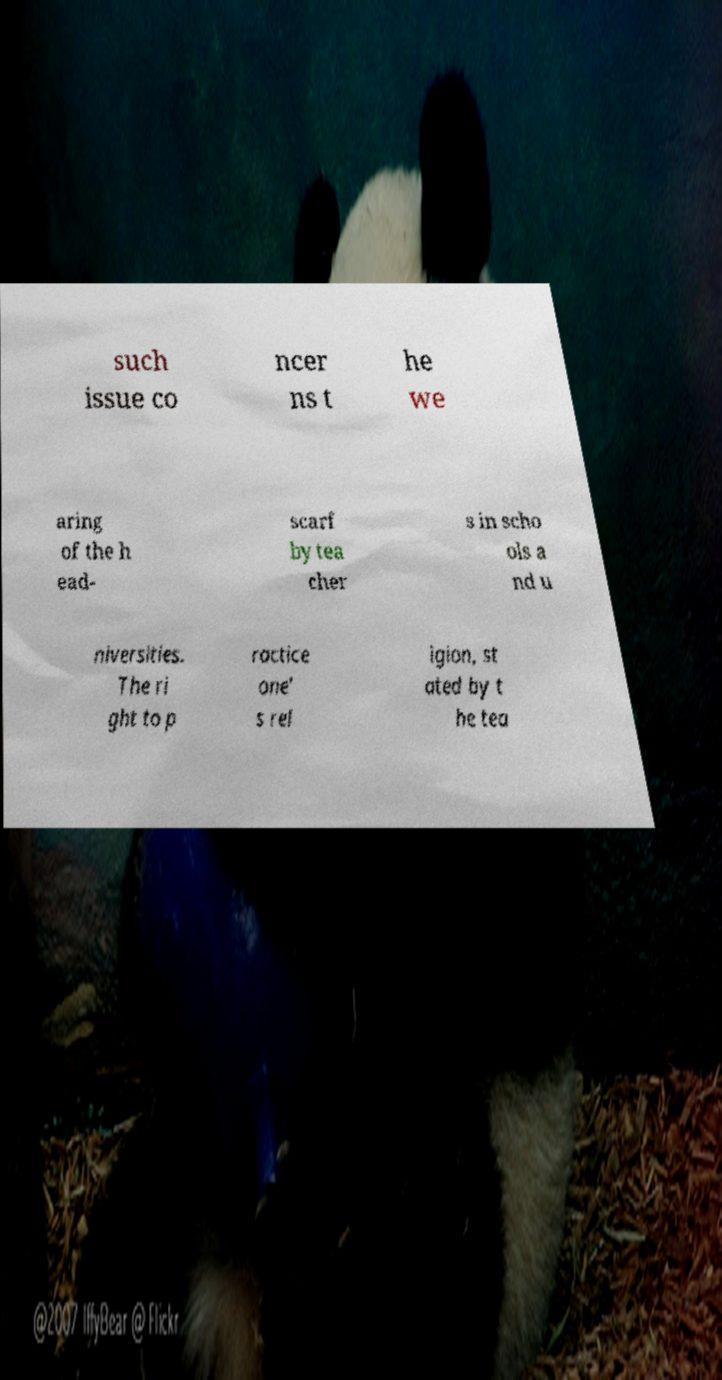Please read and relay the text visible in this image. What does it say? such issue co ncer ns t he we aring of the h ead- scarf by tea cher s in scho ols a nd u niversities. The ri ght to p ractice one' s rel igion, st ated by t he tea 